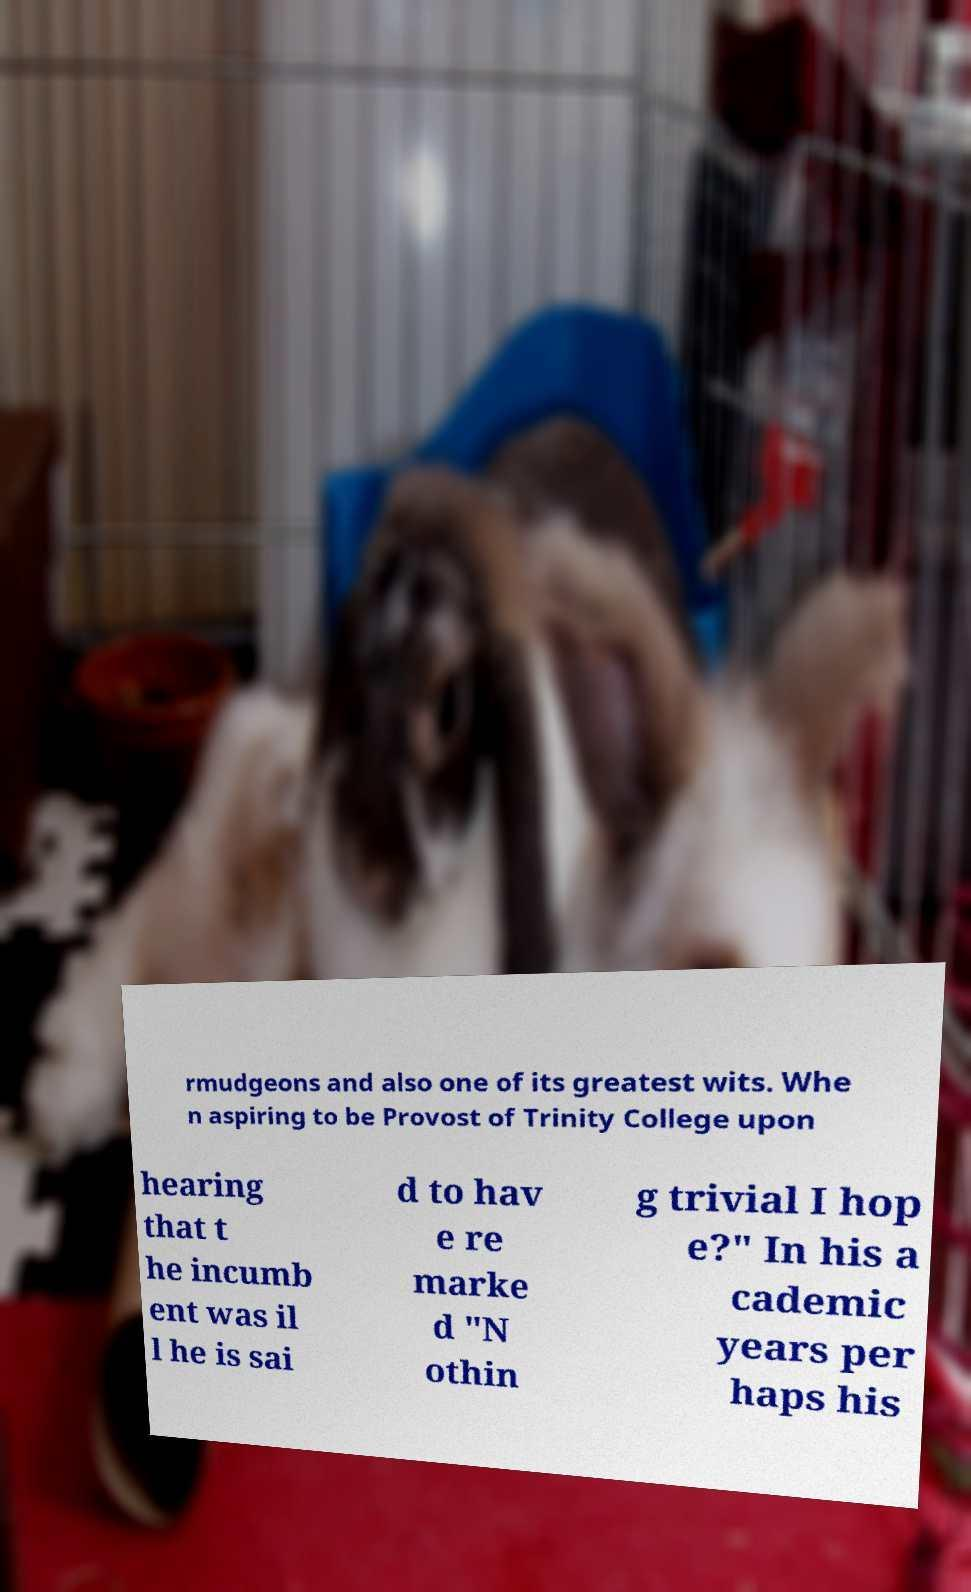Please read and relay the text visible in this image. What does it say? rmudgeons and also one of its greatest wits. Whe n aspiring to be Provost of Trinity College upon hearing that t he incumb ent was il l he is sai d to hav e re marke d "N othin g trivial I hop e?" In his a cademic years per haps his 